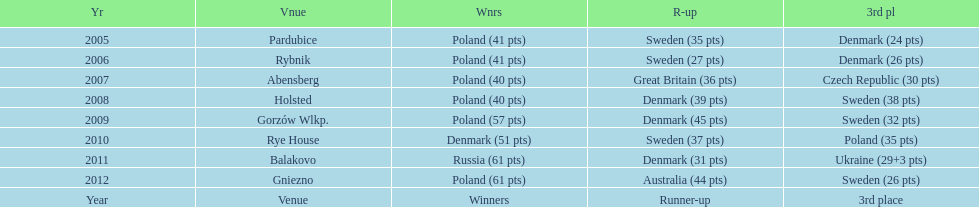What is the aggregate number of points obtained in 2009? 134. 